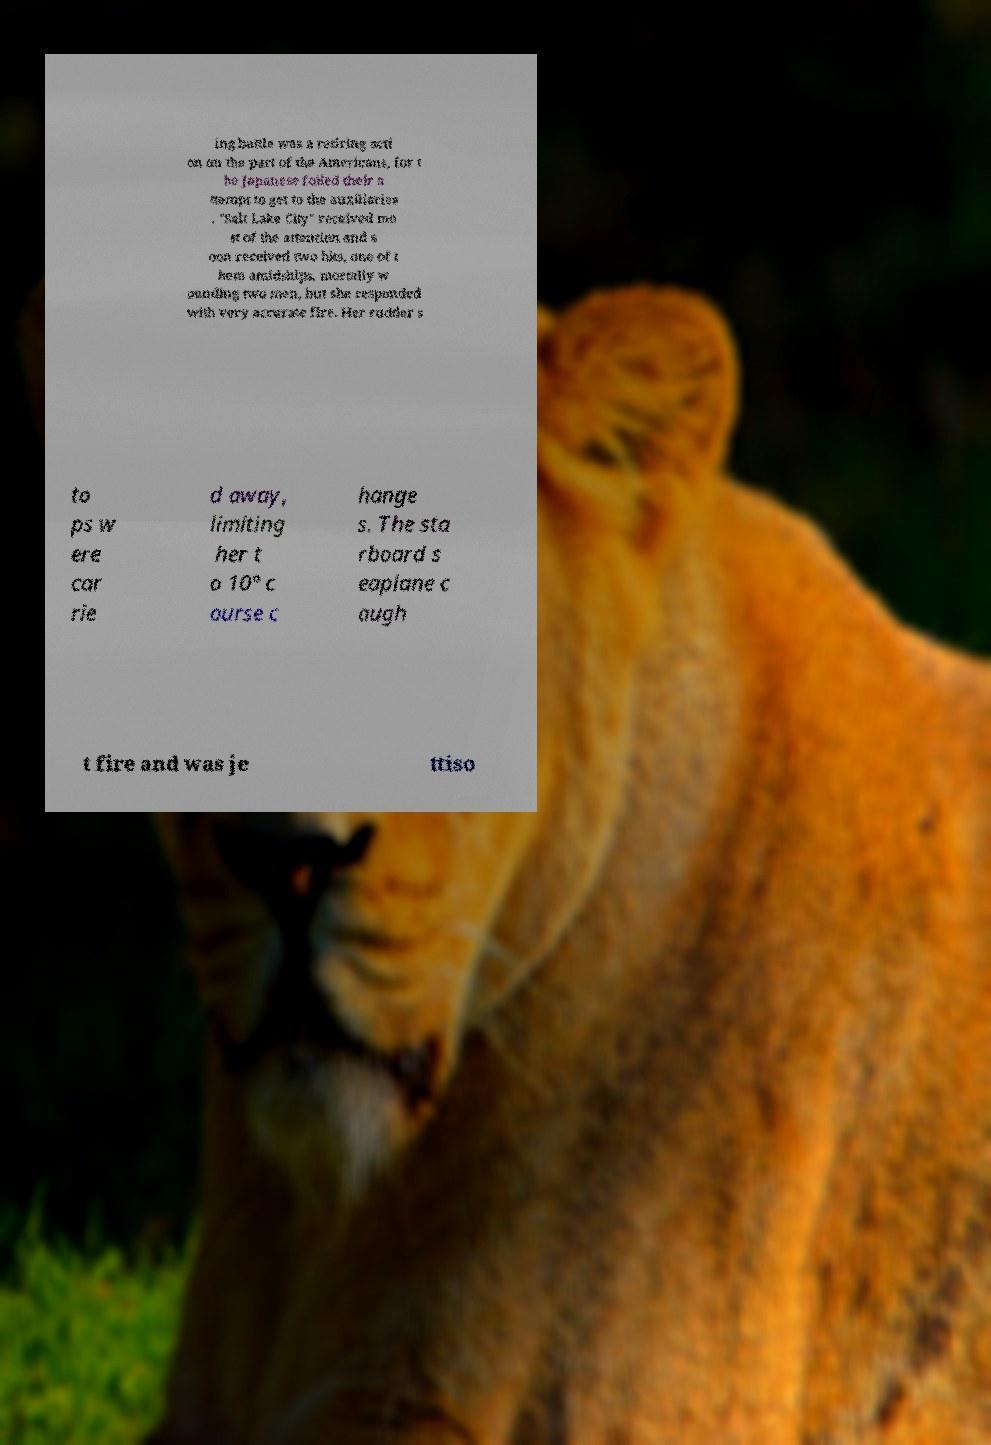Can you accurately transcribe the text from the provided image for me? ing battle was a retiring acti on on the part of the Americans, for t he Japanese foiled their a ttempt to get to the auxiliaries . "Salt Lake City" received mo st of the attention and s oon received two hits, one of t hem amidships, mortally w ounding two men, but she responded with very accurate fire. Her rudder s to ps w ere car rie d away, limiting her t o 10° c ourse c hange s. The sta rboard s eaplane c augh t fire and was je ttiso 